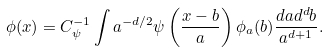Convert formula to latex. <formula><loc_0><loc_0><loc_500><loc_500>\phi ( x ) = C _ { \psi } ^ { - 1 } \int a ^ { - d / 2 } \psi \left ( \frac { x - b } { a } \right ) \phi _ { a } ( b ) \frac { d a d ^ { d } b } { a ^ { d + 1 } } .</formula> 